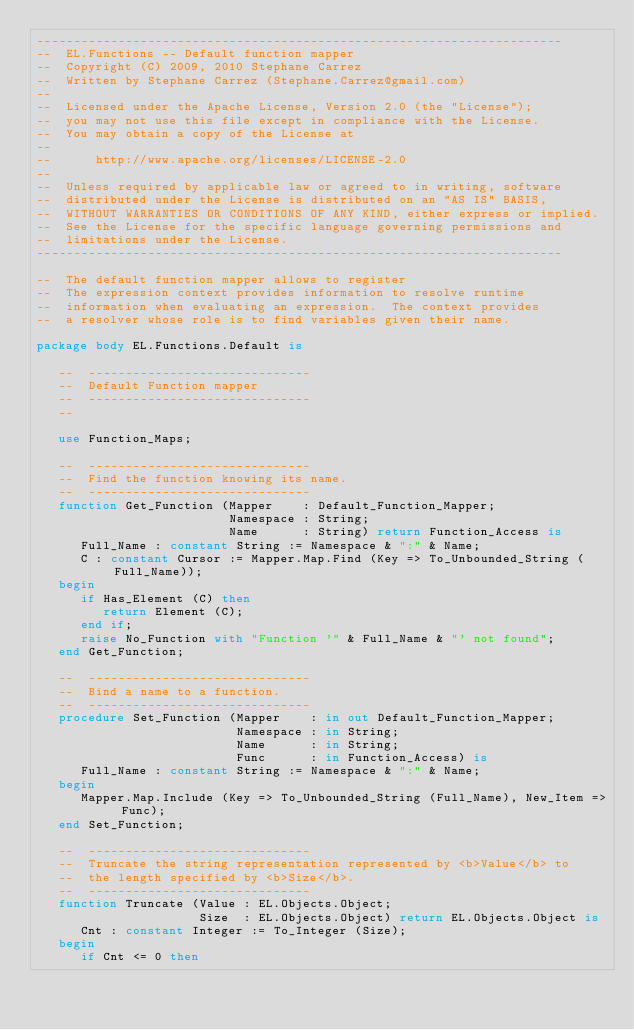<code> <loc_0><loc_0><loc_500><loc_500><_Ada_>-----------------------------------------------------------------------
--  EL.Functions -- Default function mapper
--  Copyright (C) 2009, 2010 Stephane Carrez
--  Written by Stephane Carrez (Stephane.Carrez@gmail.com)
--
--  Licensed under the Apache License, Version 2.0 (the "License");
--  you may not use this file except in compliance with the License.
--  You may obtain a copy of the License at
--
--      http://www.apache.org/licenses/LICENSE-2.0
--
--  Unless required by applicable law or agreed to in writing, software
--  distributed under the License is distributed on an "AS IS" BASIS,
--  WITHOUT WARRANTIES OR CONDITIONS OF ANY KIND, either express or implied.
--  See the License for the specific language governing permissions and
--  limitations under the License.
-----------------------------------------------------------------------

--  The default function mapper allows to register
--  The expression context provides information to resolve runtime
--  information when evaluating an expression.  The context provides
--  a resolver whose role is to find variables given their name.

package body EL.Functions.Default is

   --  ------------------------------
   --  Default Function mapper
   --  ------------------------------
   --

   use Function_Maps;

   --  ------------------------------
   --  Find the function knowing its name.
   --  ------------------------------
   function Get_Function (Mapper    : Default_Function_Mapper;
                          Namespace : String;
                          Name      : String) return Function_Access is
      Full_Name : constant String := Namespace & ":" & Name;
      C : constant Cursor := Mapper.Map.Find (Key => To_Unbounded_String (Full_Name));
   begin
      if Has_Element (C) then
         return Element (C);
      end if;
      raise No_Function with "Function '" & Full_Name & "' not found";
   end Get_Function;

   --  ------------------------------
   --  Bind a name to a function.
   --  ------------------------------
   procedure Set_Function (Mapper    : in out Default_Function_Mapper;
                           Namespace : in String;
                           Name      : in String;
                           Func      : in Function_Access) is
      Full_Name : constant String := Namespace & ":" & Name;
   begin
      Mapper.Map.Include (Key => To_Unbounded_String (Full_Name), New_Item => Func);
   end Set_Function;

   --  ------------------------------
   --  Truncate the string representation represented by <b>Value</b> to
   --  the length specified by <b>Size</b>.
   --  ------------------------------
   function Truncate (Value : EL.Objects.Object;
                      Size  : EL.Objects.Object) return EL.Objects.Object is
      Cnt : constant Integer := To_Integer (Size);
   begin
      if Cnt <= 0 then</code> 